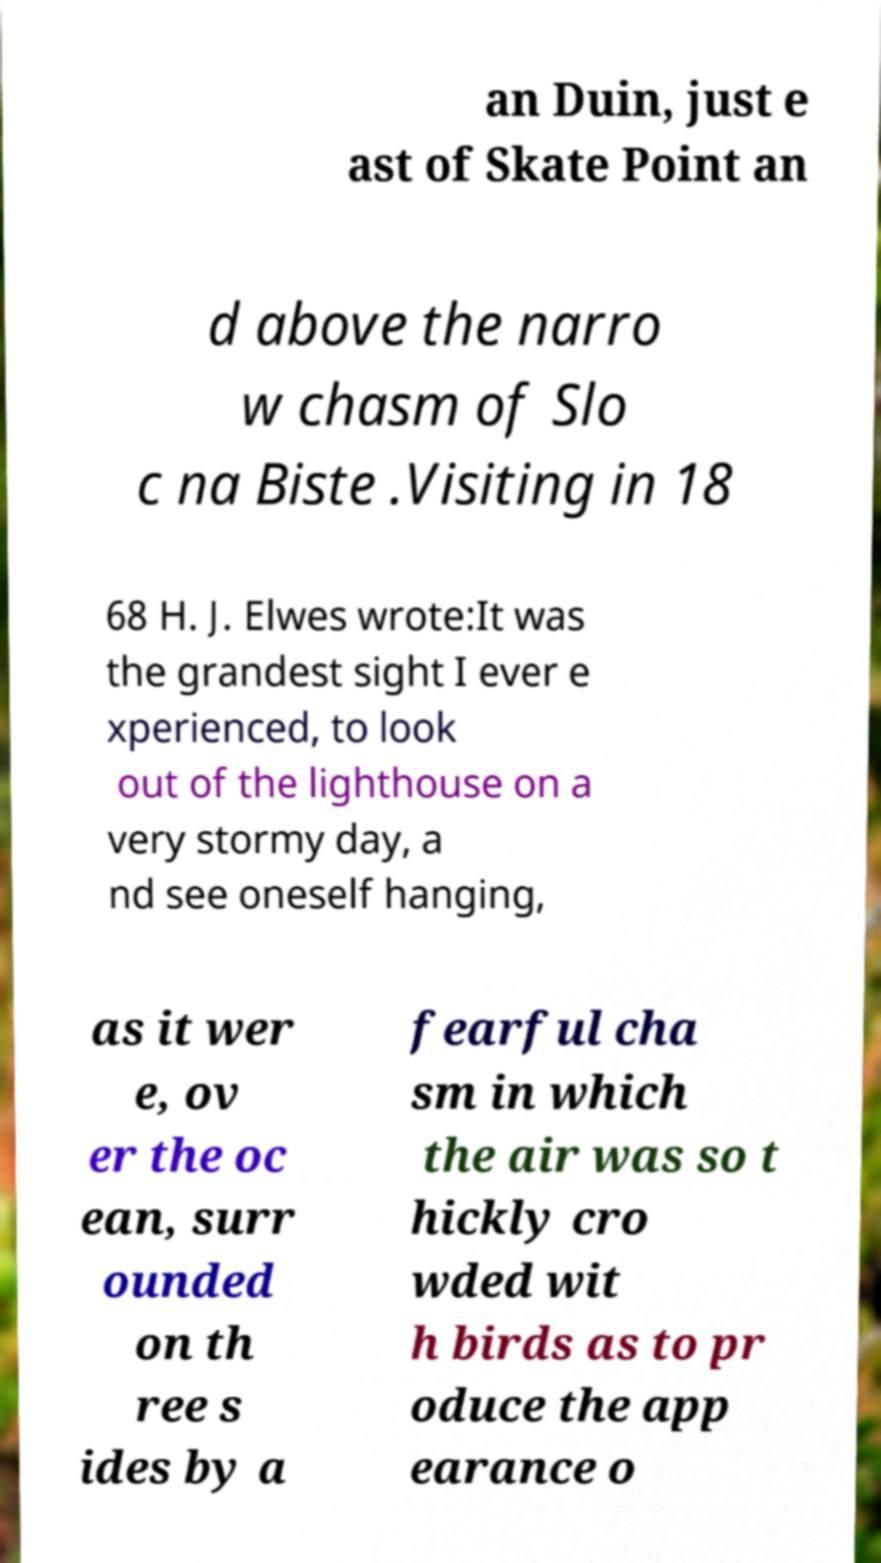Could you extract and type out the text from this image? an Duin, just e ast of Skate Point an d above the narro w chasm of Slo c na Biste .Visiting in 18 68 H. J. Elwes wrote:It was the grandest sight I ever e xperienced, to look out of the lighthouse on a very stormy day, a nd see oneself hanging, as it wer e, ov er the oc ean, surr ounded on th ree s ides by a fearful cha sm in which the air was so t hickly cro wded wit h birds as to pr oduce the app earance o 